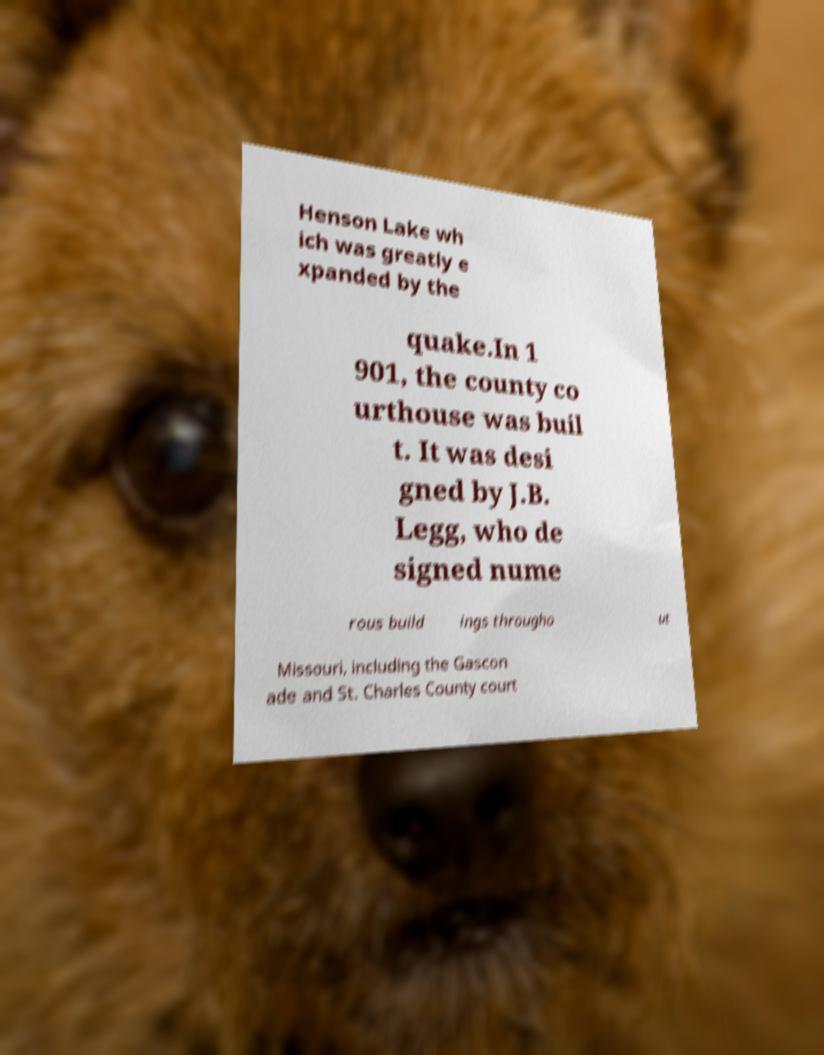Can you read and provide the text displayed in the image?This photo seems to have some interesting text. Can you extract and type it out for me? Henson Lake wh ich was greatly e xpanded by the quake.In 1 901, the county co urthouse was buil t. It was desi gned by J.B. Legg, who de signed nume rous build ings througho ut Missouri, including the Gascon ade and St. Charles County court 